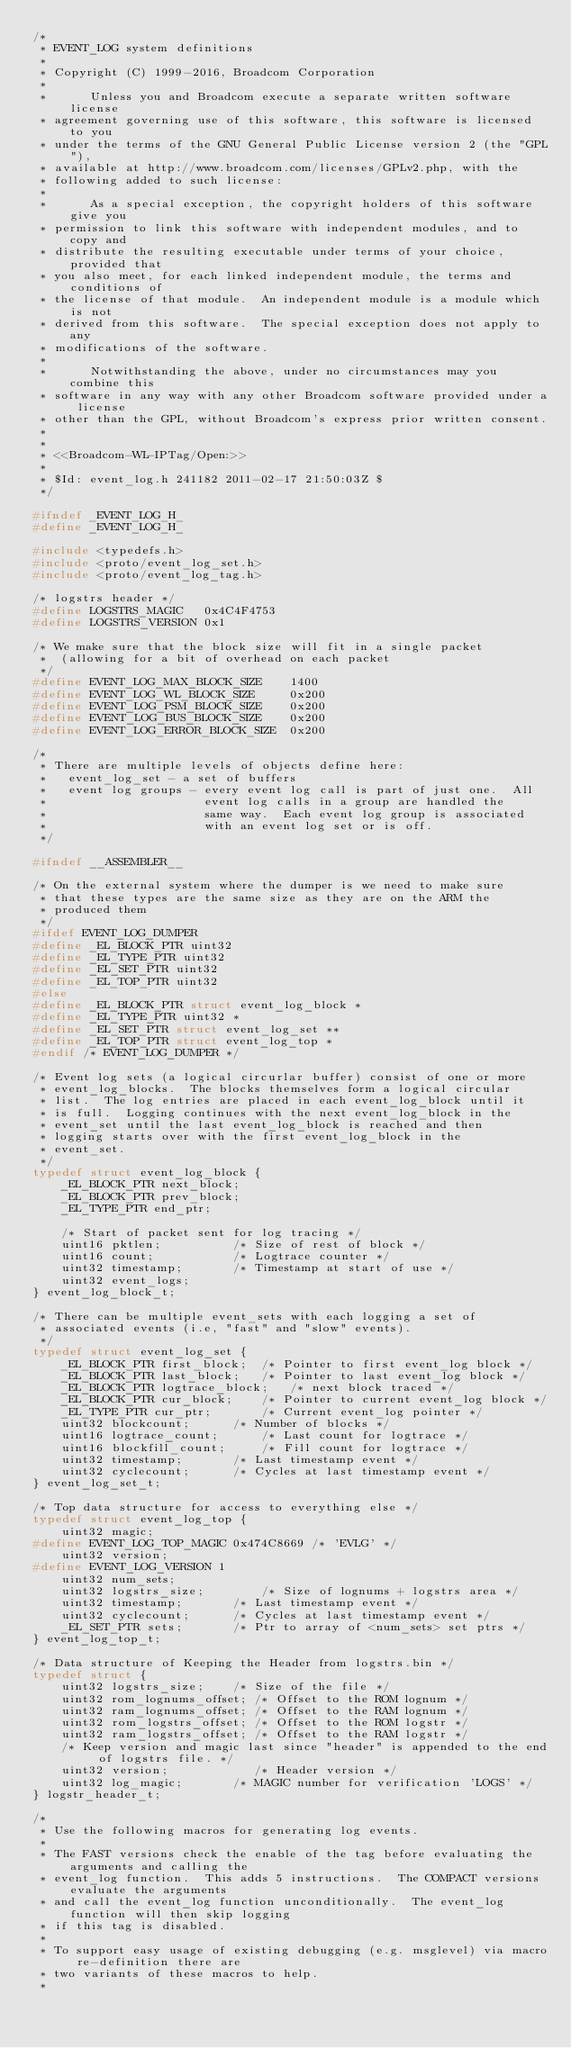Convert code to text. <code><loc_0><loc_0><loc_500><loc_500><_C_>/*
 * EVENT_LOG system definitions
 *
 * Copyright (C) 1999-2016, Broadcom Corporation
 * 
 *      Unless you and Broadcom execute a separate written software license
 * agreement governing use of this software, this software is licensed to you
 * under the terms of the GNU General Public License version 2 (the "GPL"),
 * available at http://www.broadcom.com/licenses/GPLv2.php, with the
 * following added to such license:
 * 
 *      As a special exception, the copyright holders of this software give you
 * permission to link this software with independent modules, and to copy and
 * distribute the resulting executable under terms of your choice, provided that
 * you also meet, for each linked independent module, the terms and conditions of
 * the license of that module.  An independent module is a module which is not
 * derived from this software.  The special exception does not apply to any
 * modifications of the software.
 * 
 *      Notwithstanding the above, under no circumstances may you combine this
 * software in any way with any other Broadcom software provided under a license
 * other than the GPL, without Broadcom's express prior written consent.
 *
 *
 * <<Broadcom-WL-IPTag/Open:>>
 *
 * $Id: event_log.h 241182 2011-02-17 21:50:03Z $
 */

#ifndef _EVENT_LOG_H_
#define _EVENT_LOG_H_

#include <typedefs.h>
#include <proto/event_log_set.h>
#include <proto/event_log_tag.h>

/* logstrs header */
#define LOGSTRS_MAGIC   0x4C4F4753
#define LOGSTRS_VERSION 0x1

/* We make sure that the block size will fit in a single packet
 *  (allowing for a bit of overhead on each packet
 */
#define EVENT_LOG_MAX_BLOCK_SIZE	1400
#define EVENT_LOG_WL_BLOCK_SIZE		0x200
#define EVENT_LOG_PSM_BLOCK_SIZE	0x200
#define EVENT_LOG_BUS_BLOCK_SIZE	0x200
#define EVENT_LOG_ERROR_BLOCK_SIZE	0x200

/*
 * There are multiple levels of objects define here:
 *   event_log_set - a set of buffers
 *   event log groups - every event log call is part of just one.  All
 *                      event log calls in a group are handled the
 *                      same way.  Each event log group is associated
 *                      with an event log set or is off.
 */

#ifndef __ASSEMBLER__

/* On the external system where the dumper is we need to make sure
 * that these types are the same size as they are on the ARM the
 * produced them
 */
#ifdef EVENT_LOG_DUMPER
#define _EL_BLOCK_PTR uint32
#define _EL_TYPE_PTR uint32
#define _EL_SET_PTR uint32
#define _EL_TOP_PTR uint32
#else
#define _EL_BLOCK_PTR struct event_log_block *
#define _EL_TYPE_PTR uint32 *
#define _EL_SET_PTR struct event_log_set **
#define _EL_TOP_PTR struct event_log_top *
#endif /* EVENT_LOG_DUMPER */

/* Event log sets (a logical circurlar buffer) consist of one or more
 * event_log_blocks.  The blocks themselves form a logical circular
 * list.  The log entries are placed in each event_log_block until it
 * is full.  Logging continues with the next event_log_block in the
 * event_set until the last event_log_block is reached and then
 * logging starts over with the first event_log_block in the
 * event_set.
 */
typedef struct event_log_block {
	_EL_BLOCK_PTR next_block;
	_EL_BLOCK_PTR prev_block;
	_EL_TYPE_PTR end_ptr;

	/* Start of packet sent for log tracing */
	uint16 pktlen;			/* Size of rest of block */
	uint16 count;			/* Logtrace counter */
	uint32 timestamp;		/* Timestamp at start of use */
	uint32 event_logs;
} event_log_block_t;

/* There can be multiple event_sets with each logging a set of
 * associated events (i.e, "fast" and "slow" events).
 */
typedef struct event_log_set {
	_EL_BLOCK_PTR first_block; 	/* Pointer to first event_log block */
	_EL_BLOCK_PTR last_block; 	/* Pointer to last event_log block */
	_EL_BLOCK_PTR logtrace_block;	/* next block traced */
	_EL_BLOCK_PTR cur_block;   	/* Pointer to current event_log block */
	_EL_TYPE_PTR cur_ptr;      	/* Current event_log pointer */
	uint32 blockcount;		/* Number of blocks */
	uint16 logtrace_count;		/* Last count for logtrace */
	uint16 blockfill_count;		/* Fill count for logtrace */
	uint32 timestamp;		/* Last timestamp event */
	uint32 cyclecount;		/* Cycles at last timestamp event */
} event_log_set_t;

/* Top data structure for access to everything else */
typedef struct event_log_top {
	uint32 magic;
#define EVENT_LOG_TOP_MAGIC 0x474C8669 /* 'EVLG' */
	uint32 version;
#define EVENT_LOG_VERSION 1
	uint32 num_sets;
	uint32 logstrs_size;		/* Size of lognums + logstrs area */
	uint32 timestamp;		/* Last timestamp event */
	uint32 cyclecount;		/* Cycles at last timestamp event */
	_EL_SET_PTR sets; 		/* Ptr to array of <num_sets> set ptrs */
} event_log_top_t;

/* Data structure of Keeping the Header from logstrs.bin */
typedef struct {
	uint32 logstrs_size;    /* Size of the file */
	uint32 rom_lognums_offset; /* Offset to the ROM lognum */
	uint32 ram_lognums_offset; /* Offset to the RAM lognum */
	uint32 rom_logstrs_offset; /* Offset to the ROM logstr */
	uint32 ram_logstrs_offset; /* Offset to the RAM logstr */
	/* Keep version and magic last since "header" is appended to the end of logstrs file. */
	uint32 version;            /* Header version */
	uint32 log_magic;       /* MAGIC number for verification 'LOGS' */
} logstr_header_t;

/*
 * Use the following macros for generating log events.
 *
 * The FAST versions check the enable of the tag before evaluating the arguments and calling the
 * event_log function.  This adds 5 instructions.  The COMPACT versions evaluate the arguments
 * and call the event_log function unconditionally.  The event_log function will then skip logging
 * if this tag is disabled.
 *
 * To support easy usage of existing debugging (e.g. msglevel) via macro re-definition there are
 * two variants of these macros to help.
 *</code> 